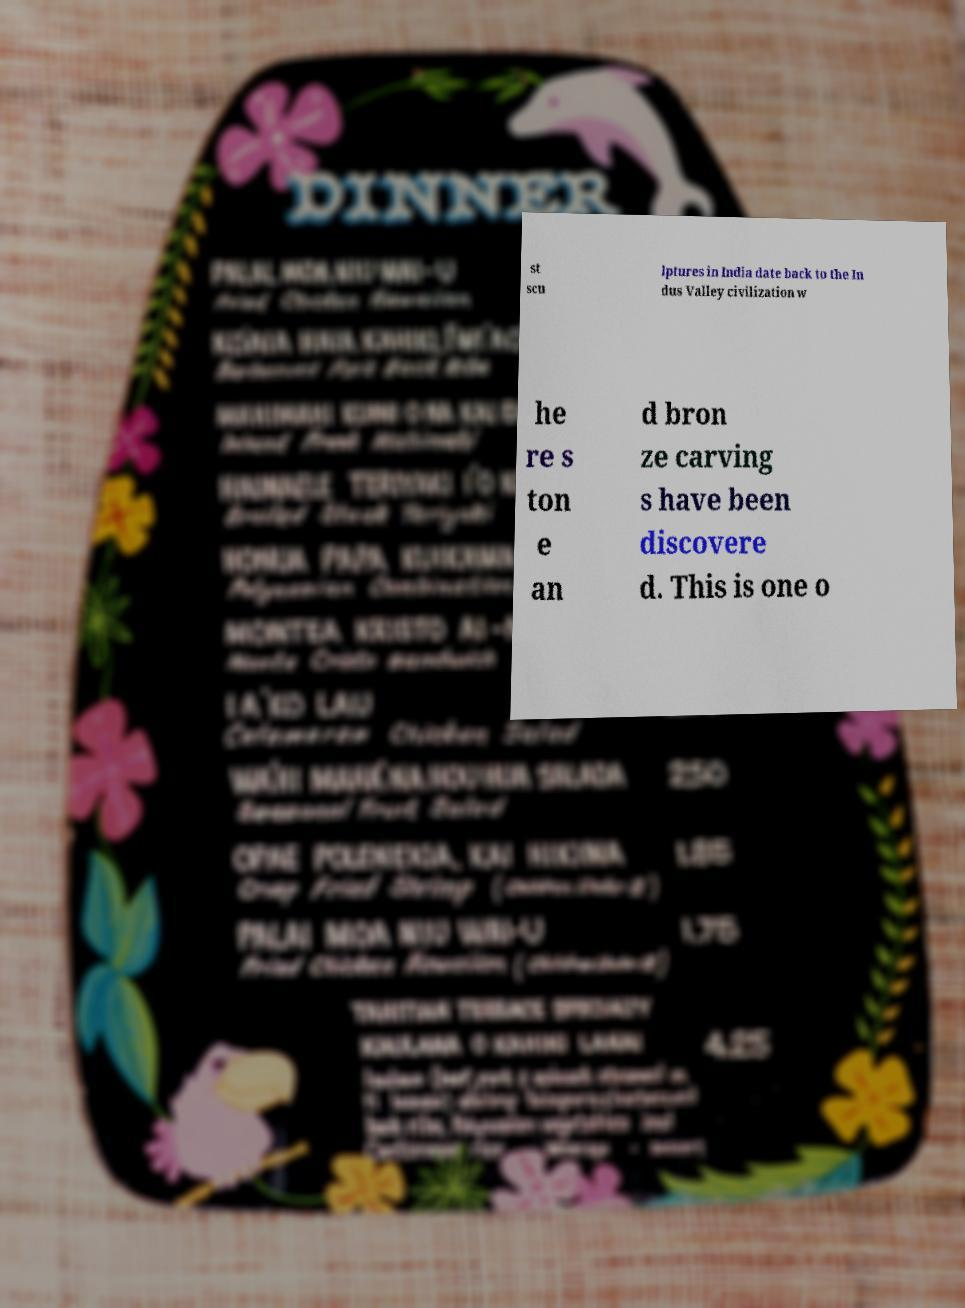Can you accurately transcribe the text from the provided image for me? st scu lptures in India date back to the In dus Valley civilization w he re s ton e an d bron ze carving s have been discovere d. This is one o 